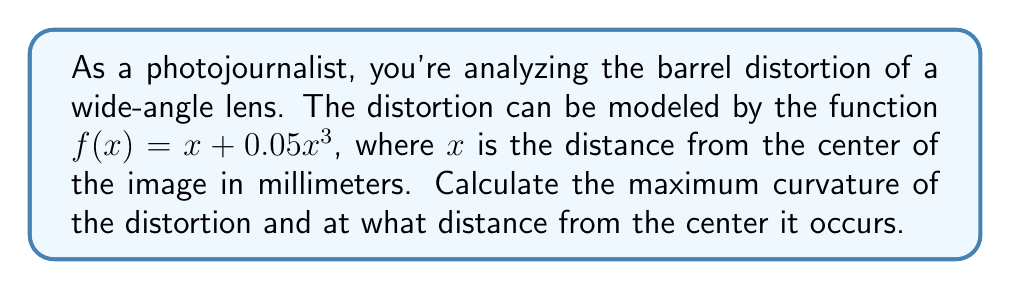Teach me how to tackle this problem. To solve this problem, we'll follow these steps:

1) The curvature of a function $f(x)$ is given by:

   $$\kappa(x) = \frac{|f''(x)|}{(1 + [f'(x)]^2)^{3/2}}$$

2) First, let's find $f'(x)$ and $f''(x)$:
   
   $f'(x) = 1 + 0.15x^2$
   $f''(x) = 0.3x$

3) Substituting these into the curvature formula:

   $$\kappa(x) = \frac{|0.3x|}{(1 + [1 + 0.15x^2]^2)^{3/2}}$$

4) To find the maximum curvature, we need to find where $\frac{d\kappa}{dx} = 0$. However, this leads to a complex equation. Instead, we can observe that the curvature will be maximum when $|f''(x)|$ is largest relative to $(1 + [f'(x)]^2)^{3/2}$.

5) Given the symmetry of the function, this will occur at the point where $f'''(x) = 0$. 

   $f'''(x) = 0.3$

6) Since $f'''(x)$ is constant, the maximum curvature occurs at $x = 0$.

7) Evaluating $\kappa(0)$:

   $$\kappa(0) = \frac{|0.3 \cdot 0|}{(1 + [1 + 0.15 \cdot 0^2]^2)^{3/2}} = 0$$
Answer: Maximum curvature: 0, occurring at the center (x = 0 mm) 